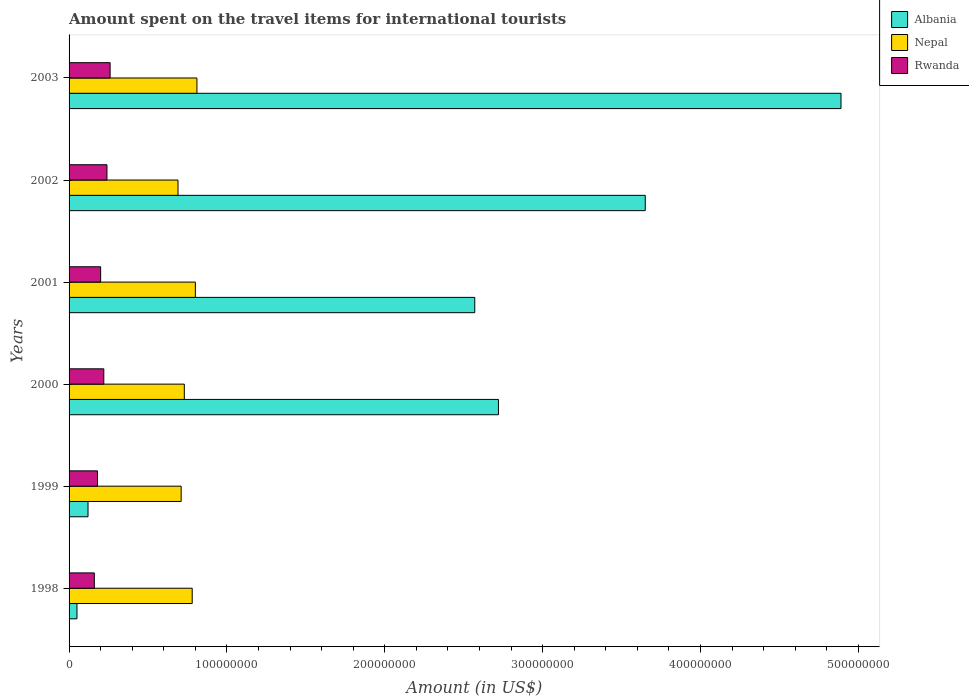How many groups of bars are there?
Make the answer very short. 6. How many bars are there on the 5th tick from the bottom?
Your answer should be compact. 3. What is the label of the 3rd group of bars from the top?
Your response must be concise. 2001. In how many cases, is the number of bars for a given year not equal to the number of legend labels?
Give a very brief answer. 0. What is the amount spent on the travel items for international tourists in Nepal in 2002?
Keep it short and to the point. 6.90e+07. Across all years, what is the maximum amount spent on the travel items for international tourists in Nepal?
Your response must be concise. 8.10e+07. Across all years, what is the minimum amount spent on the travel items for international tourists in Nepal?
Keep it short and to the point. 6.90e+07. What is the total amount spent on the travel items for international tourists in Albania in the graph?
Your answer should be very brief. 1.40e+09. What is the difference between the amount spent on the travel items for international tourists in Nepal in 2001 and that in 2002?
Provide a succinct answer. 1.10e+07. What is the difference between the amount spent on the travel items for international tourists in Albania in 1998 and the amount spent on the travel items for international tourists in Rwanda in 2002?
Give a very brief answer. -1.90e+07. What is the average amount spent on the travel items for international tourists in Rwanda per year?
Your response must be concise. 2.10e+07. In the year 2003, what is the difference between the amount spent on the travel items for international tourists in Nepal and amount spent on the travel items for international tourists in Rwanda?
Provide a succinct answer. 5.50e+07. In how many years, is the amount spent on the travel items for international tourists in Albania greater than 480000000 US$?
Offer a terse response. 1. Is the amount spent on the travel items for international tourists in Albania in 1998 less than that in 2003?
Your response must be concise. Yes. Is the difference between the amount spent on the travel items for international tourists in Nepal in 1999 and 2001 greater than the difference between the amount spent on the travel items for international tourists in Rwanda in 1999 and 2001?
Give a very brief answer. No. What is the difference between the highest and the lowest amount spent on the travel items for international tourists in Albania?
Your response must be concise. 4.84e+08. In how many years, is the amount spent on the travel items for international tourists in Albania greater than the average amount spent on the travel items for international tourists in Albania taken over all years?
Make the answer very short. 4. What does the 2nd bar from the top in 2000 represents?
Give a very brief answer. Nepal. What does the 2nd bar from the bottom in 2003 represents?
Your answer should be compact. Nepal. Is it the case that in every year, the sum of the amount spent on the travel items for international tourists in Rwanda and amount spent on the travel items for international tourists in Nepal is greater than the amount spent on the travel items for international tourists in Albania?
Your answer should be compact. No. How many bars are there?
Keep it short and to the point. 18. Are all the bars in the graph horizontal?
Give a very brief answer. Yes. How many years are there in the graph?
Your answer should be compact. 6. What is the difference between two consecutive major ticks on the X-axis?
Provide a short and direct response. 1.00e+08. Are the values on the major ticks of X-axis written in scientific E-notation?
Your response must be concise. No. Where does the legend appear in the graph?
Keep it short and to the point. Top right. How many legend labels are there?
Offer a very short reply. 3. What is the title of the graph?
Offer a very short reply. Amount spent on the travel items for international tourists. What is the label or title of the X-axis?
Make the answer very short. Amount (in US$). What is the Amount (in US$) in Albania in 1998?
Your answer should be very brief. 5.00e+06. What is the Amount (in US$) in Nepal in 1998?
Make the answer very short. 7.80e+07. What is the Amount (in US$) of Rwanda in 1998?
Your answer should be compact. 1.60e+07. What is the Amount (in US$) in Albania in 1999?
Your answer should be very brief. 1.20e+07. What is the Amount (in US$) of Nepal in 1999?
Your answer should be very brief. 7.10e+07. What is the Amount (in US$) of Rwanda in 1999?
Make the answer very short. 1.80e+07. What is the Amount (in US$) of Albania in 2000?
Make the answer very short. 2.72e+08. What is the Amount (in US$) in Nepal in 2000?
Provide a succinct answer. 7.30e+07. What is the Amount (in US$) of Rwanda in 2000?
Provide a succinct answer. 2.20e+07. What is the Amount (in US$) of Albania in 2001?
Keep it short and to the point. 2.57e+08. What is the Amount (in US$) of Nepal in 2001?
Ensure brevity in your answer.  8.00e+07. What is the Amount (in US$) of Rwanda in 2001?
Offer a terse response. 2.00e+07. What is the Amount (in US$) in Albania in 2002?
Provide a succinct answer. 3.65e+08. What is the Amount (in US$) of Nepal in 2002?
Keep it short and to the point. 6.90e+07. What is the Amount (in US$) of Rwanda in 2002?
Give a very brief answer. 2.40e+07. What is the Amount (in US$) of Albania in 2003?
Offer a terse response. 4.89e+08. What is the Amount (in US$) in Nepal in 2003?
Provide a short and direct response. 8.10e+07. What is the Amount (in US$) in Rwanda in 2003?
Give a very brief answer. 2.60e+07. Across all years, what is the maximum Amount (in US$) of Albania?
Give a very brief answer. 4.89e+08. Across all years, what is the maximum Amount (in US$) in Nepal?
Your response must be concise. 8.10e+07. Across all years, what is the maximum Amount (in US$) of Rwanda?
Ensure brevity in your answer.  2.60e+07. Across all years, what is the minimum Amount (in US$) of Albania?
Provide a succinct answer. 5.00e+06. Across all years, what is the minimum Amount (in US$) in Nepal?
Provide a short and direct response. 6.90e+07. Across all years, what is the minimum Amount (in US$) in Rwanda?
Ensure brevity in your answer.  1.60e+07. What is the total Amount (in US$) in Albania in the graph?
Provide a succinct answer. 1.40e+09. What is the total Amount (in US$) of Nepal in the graph?
Your answer should be very brief. 4.52e+08. What is the total Amount (in US$) in Rwanda in the graph?
Keep it short and to the point. 1.26e+08. What is the difference between the Amount (in US$) in Albania in 1998 and that in 1999?
Make the answer very short. -7.00e+06. What is the difference between the Amount (in US$) in Albania in 1998 and that in 2000?
Provide a succinct answer. -2.67e+08. What is the difference between the Amount (in US$) in Nepal in 1998 and that in 2000?
Offer a very short reply. 5.00e+06. What is the difference between the Amount (in US$) in Rwanda in 1998 and that in 2000?
Ensure brevity in your answer.  -6.00e+06. What is the difference between the Amount (in US$) in Albania in 1998 and that in 2001?
Offer a terse response. -2.52e+08. What is the difference between the Amount (in US$) in Albania in 1998 and that in 2002?
Make the answer very short. -3.60e+08. What is the difference between the Amount (in US$) of Nepal in 1998 and that in 2002?
Provide a short and direct response. 9.00e+06. What is the difference between the Amount (in US$) in Rwanda in 1998 and that in 2002?
Offer a terse response. -8.00e+06. What is the difference between the Amount (in US$) of Albania in 1998 and that in 2003?
Offer a very short reply. -4.84e+08. What is the difference between the Amount (in US$) in Rwanda in 1998 and that in 2003?
Your answer should be very brief. -1.00e+07. What is the difference between the Amount (in US$) of Albania in 1999 and that in 2000?
Your response must be concise. -2.60e+08. What is the difference between the Amount (in US$) of Albania in 1999 and that in 2001?
Provide a short and direct response. -2.45e+08. What is the difference between the Amount (in US$) in Nepal in 1999 and that in 2001?
Offer a very short reply. -9.00e+06. What is the difference between the Amount (in US$) of Rwanda in 1999 and that in 2001?
Your answer should be compact. -2.00e+06. What is the difference between the Amount (in US$) in Albania in 1999 and that in 2002?
Your response must be concise. -3.53e+08. What is the difference between the Amount (in US$) in Nepal in 1999 and that in 2002?
Offer a very short reply. 2.00e+06. What is the difference between the Amount (in US$) of Rwanda in 1999 and that in 2002?
Provide a succinct answer. -6.00e+06. What is the difference between the Amount (in US$) in Albania in 1999 and that in 2003?
Offer a very short reply. -4.77e+08. What is the difference between the Amount (in US$) of Nepal in 1999 and that in 2003?
Your response must be concise. -1.00e+07. What is the difference between the Amount (in US$) of Rwanda in 1999 and that in 2003?
Ensure brevity in your answer.  -8.00e+06. What is the difference between the Amount (in US$) in Albania in 2000 and that in 2001?
Offer a very short reply. 1.50e+07. What is the difference between the Amount (in US$) in Nepal in 2000 and that in 2001?
Your answer should be compact. -7.00e+06. What is the difference between the Amount (in US$) in Albania in 2000 and that in 2002?
Provide a short and direct response. -9.30e+07. What is the difference between the Amount (in US$) of Nepal in 2000 and that in 2002?
Keep it short and to the point. 4.00e+06. What is the difference between the Amount (in US$) of Albania in 2000 and that in 2003?
Make the answer very short. -2.17e+08. What is the difference between the Amount (in US$) of Nepal in 2000 and that in 2003?
Offer a very short reply. -8.00e+06. What is the difference between the Amount (in US$) in Rwanda in 2000 and that in 2003?
Provide a succinct answer. -4.00e+06. What is the difference between the Amount (in US$) of Albania in 2001 and that in 2002?
Make the answer very short. -1.08e+08. What is the difference between the Amount (in US$) in Nepal in 2001 and that in 2002?
Make the answer very short. 1.10e+07. What is the difference between the Amount (in US$) of Rwanda in 2001 and that in 2002?
Make the answer very short. -4.00e+06. What is the difference between the Amount (in US$) in Albania in 2001 and that in 2003?
Make the answer very short. -2.32e+08. What is the difference between the Amount (in US$) in Rwanda in 2001 and that in 2003?
Provide a succinct answer. -6.00e+06. What is the difference between the Amount (in US$) in Albania in 2002 and that in 2003?
Offer a terse response. -1.24e+08. What is the difference between the Amount (in US$) of Nepal in 2002 and that in 2003?
Your answer should be compact. -1.20e+07. What is the difference between the Amount (in US$) of Rwanda in 2002 and that in 2003?
Make the answer very short. -2.00e+06. What is the difference between the Amount (in US$) in Albania in 1998 and the Amount (in US$) in Nepal in 1999?
Give a very brief answer. -6.60e+07. What is the difference between the Amount (in US$) of Albania in 1998 and the Amount (in US$) of Rwanda in 1999?
Your answer should be compact. -1.30e+07. What is the difference between the Amount (in US$) in Nepal in 1998 and the Amount (in US$) in Rwanda in 1999?
Provide a short and direct response. 6.00e+07. What is the difference between the Amount (in US$) in Albania in 1998 and the Amount (in US$) in Nepal in 2000?
Make the answer very short. -6.80e+07. What is the difference between the Amount (in US$) in Albania in 1998 and the Amount (in US$) in Rwanda in 2000?
Keep it short and to the point. -1.70e+07. What is the difference between the Amount (in US$) of Nepal in 1998 and the Amount (in US$) of Rwanda in 2000?
Your response must be concise. 5.60e+07. What is the difference between the Amount (in US$) of Albania in 1998 and the Amount (in US$) of Nepal in 2001?
Offer a terse response. -7.50e+07. What is the difference between the Amount (in US$) in Albania in 1998 and the Amount (in US$) in Rwanda in 2001?
Your answer should be very brief. -1.50e+07. What is the difference between the Amount (in US$) of Nepal in 1998 and the Amount (in US$) of Rwanda in 2001?
Give a very brief answer. 5.80e+07. What is the difference between the Amount (in US$) in Albania in 1998 and the Amount (in US$) in Nepal in 2002?
Offer a very short reply. -6.40e+07. What is the difference between the Amount (in US$) in Albania in 1998 and the Amount (in US$) in Rwanda in 2002?
Give a very brief answer. -1.90e+07. What is the difference between the Amount (in US$) of Nepal in 1998 and the Amount (in US$) of Rwanda in 2002?
Ensure brevity in your answer.  5.40e+07. What is the difference between the Amount (in US$) of Albania in 1998 and the Amount (in US$) of Nepal in 2003?
Your response must be concise. -7.60e+07. What is the difference between the Amount (in US$) in Albania in 1998 and the Amount (in US$) in Rwanda in 2003?
Offer a very short reply. -2.10e+07. What is the difference between the Amount (in US$) in Nepal in 1998 and the Amount (in US$) in Rwanda in 2003?
Your response must be concise. 5.20e+07. What is the difference between the Amount (in US$) in Albania in 1999 and the Amount (in US$) in Nepal in 2000?
Make the answer very short. -6.10e+07. What is the difference between the Amount (in US$) in Albania in 1999 and the Amount (in US$) in Rwanda in 2000?
Offer a terse response. -1.00e+07. What is the difference between the Amount (in US$) in Nepal in 1999 and the Amount (in US$) in Rwanda in 2000?
Provide a succinct answer. 4.90e+07. What is the difference between the Amount (in US$) in Albania in 1999 and the Amount (in US$) in Nepal in 2001?
Provide a succinct answer. -6.80e+07. What is the difference between the Amount (in US$) in Albania in 1999 and the Amount (in US$) in Rwanda in 2001?
Provide a succinct answer. -8.00e+06. What is the difference between the Amount (in US$) of Nepal in 1999 and the Amount (in US$) of Rwanda in 2001?
Provide a succinct answer. 5.10e+07. What is the difference between the Amount (in US$) in Albania in 1999 and the Amount (in US$) in Nepal in 2002?
Ensure brevity in your answer.  -5.70e+07. What is the difference between the Amount (in US$) in Albania in 1999 and the Amount (in US$) in Rwanda in 2002?
Give a very brief answer. -1.20e+07. What is the difference between the Amount (in US$) of Nepal in 1999 and the Amount (in US$) of Rwanda in 2002?
Offer a terse response. 4.70e+07. What is the difference between the Amount (in US$) in Albania in 1999 and the Amount (in US$) in Nepal in 2003?
Your answer should be compact. -6.90e+07. What is the difference between the Amount (in US$) of Albania in 1999 and the Amount (in US$) of Rwanda in 2003?
Give a very brief answer. -1.40e+07. What is the difference between the Amount (in US$) of Nepal in 1999 and the Amount (in US$) of Rwanda in 2003?
Give a very brief answer. 4.50e+07. What is the difference between the Amount (in US$) in Albania in 2000 and the Amount (in US$) in Nepal in 2001?
Provide a short and direct response. 1.92e+08. What is the difference between the Amount (in US$) of Albania in 2000 and the Amount (in US$) of Rwanda in 2001?
Your answer should be very brief. 2.52e+08. What is the difference between the Amount (in US$) in Nepal in 2000 and the Amount (in US$) in Rwanda in 2001?
Provide a succinct answer. 5.30e+07. What is the difference between the Amount (in US$) in Albania in 2000 and the Amount (in US$) in Nepal in 2002?
Offer a terse response. 2.03e+08. What is the difference between the Amount (in US$) of Albania in 2000 and the Amount (in US$) of Rwanda in 2002?
Make the answer very short. 2.48e+08. What is the difference between the Amount (in US$) in Nepal in 2000 and the Amount (in US$) in Rwanda in 2002?
Provide a short and direct response. 4.90e+07. What is the difference between the Amount (in US$) of Albania in 2000 and the Amount (in US$) of Nepal in 2003?
Provide a short and direct response. 1.91e+08. What is the difference between the Amount (in US$) in Albania in 2000 and the Amount (in US$) in Rwanda in 2003?
Make the answer very short. 2.46e+08. What is the difference between the Amount (in US$) of Nepal in 2000 and the Amount (in US$) of Rwanda in 2003?
Offer a very short reply. 4.70e+07. What is the difference between the Amount (in US$) of Albania in 2001 and the Amount (in US$) of Nepal in 2002?
Provide a short and direct response. 1.88e+08. What is the difference between the Amount (in US$) in Albania in 2001 and the Amount (in US$) in Rwanda in 2002?
Make the answer very short. 2.33e+08. What is the difference between the Amount (in US$) of Nepal in 2001 and the Amount (in US$) of Rwanda in 2002?
Your answer should be compact. 5.60e+07. What is the difference between the Amount (in US$) of Albania in 2001 and the Amount (in US$) of Nepal in 2003?
Your answer should be very brief. 1.76e+08. What is the difference between the Amount (in US$) of Albania in 2001 and the Amount (in US$) of Rwanda in 2003?
Provide a succinct answer. 2.31e+08. What is the difference between the Amount (in US$) in Nepal in 2001 and the Amount (in US$) in Rwanda in 2003?
Ensure brevity in your answer.  5.40e+07. What is the difference between the Amount (in US$) in Albania in 2002 and the Amount (in US$) in Nepal in 2003?
Your response must be concise. 2.84e+08. What is the difference between the Amount (in US$) of Albania in 2002 and the Amount (in US$) of Rwanda in 2003?
Keep it short and to the point. 3.39e+08. What is the difference between the Amount (in US$) of Nepal in 2002 and the Amount (in US$) of Rwanda in 2003?
Provide a succinct answer. 4.30e+07. What is the average Amount (in US$) in Albania per year?
Ensure brevity in your answer.  2.33e+08. What is the average Amount (in US$) in Nepal per year?
Keep it short and to the point. 7.53e+07. What is the average Amount (in US$) in Rwanda per year?
Offer a terse response. 2.10e+07. In the year 1998, what is the difference between the Amount (in US$) of Albania and Amount (in US$) of Nepal?
Make the answer very short. -7.30e+07. In the year 1998, what is the difference between the Amount (in US$) of Albania and Amount (in US$) of Rwanda?
Ensure brevity in your answer.  -1.10e+07. In the year 1998, what is the difference between the Amount (in US$) of Nepal and Amount (in US$) of Rwanda?
Your response must be concise. 6.20e+07. In the year 1999, what is the difference between the Amount (in US$) of Albania and Amount (in US$) of Nepal?
Offer a very short reply. -5.90e+07. In the year 1999, what is the difference between the Amount (in US$) of Albania and Amount (in US$) of Rwanda?
Provide a succinct answer. -6.00e+06. In the year 1999, what is the difference between the Amount (in US$) in Nepal and Amount (in US$) in Rwanda?
Your answer should be very brief. 5.30e+07. In the year 2000, what is the difference between the Amount (in US$) of Albania and Amount (in US$) of Nepal?
Offer a very short reply. 1.99e+08. In the year 2000, what is the difference between the Amount (in US$) in Albania and Amount (in US$) in Rwanda?
Your answer should be compact. 2.50e+08. In the year 2000, what is the difference between the Amount (in US$) of Nepal and Amount (in US$) of Rwanda?
Keep it short and to the point. 5.10e+07. In the year 2001, what is the difference between the Amount (in US$) of Albania and Amount (in US$) of Nepal?
Make the answer very short. 1.77e+08. In the year 2001, what is the difference between the Amount (in US$) of Albania and Amount (in US$) of Rwanda?
Offer a terse response. 2.37e+08. In the year 2001, what is the difference between the Amount (in US$) of Nepal and Amount (in US$) of Rwanda?
Ensure brevity in your answer.  6.00e+07. In the year 2002, what is the difference between the Amount (in US$) in Albania and Amount (in US$) in Nepal?
Give a very brief answer. 2.96e+08. In the year 2002, what is the difference between the Amount (in US$) of Albania and Amount (in US$) of Rwanda?
Keep it short and to the point. 3.41e+08. In the year 2002, what is the difference between the Amount (in US$) in Nepal and Amount (in US$) in Rwanda?
Your response must be concise. 4.50e+07. In the year 2003, what is the difference between the Amount (in US$) in Albania and Amount (in US$) in Nepal?
Your answer should be very brief. 4.08e+08. In the year 2003, what is the difference between the Amount (in US$) in Albania and Amount (in US$) in Rwanda?
Make the answer very short. 4.63e+08. In the year 2003, what is the difference between the Amount (in US$) of Nepal and Amount (in US$) of Rwanda?
Offer a very short reply. 5.50e+07. What is the ratio of the Amount (in US$) in Albania in 1998 to that in 1999?
Offer a very short reply. 0.42. What is the ratio of the Amount (in US$) in Nepal in 1998 to that in 1999?
Provide a succinct answer. 1.1. What is the ratio of the Amount (in US$) of Albania in 1998 to that in 2000?
Keep it short and to the point. 0.02. What is the ratio of the Amount (in US$) of Nepal in 1998 to that in 2000?
Your answer should be very brief. 1.07. What is the ratio of the Amount (in US$) of Rwanda in 1998 to that in 2000?
Provide a short and direct response. 0.73. What is the ratio of the Amount (in US$) of Albania in 1998 to that in 2001?
Provide a succinct answer. 0.02. What is the ratio of the Amount (in US$) in Nepal in 1998 to that in 2001?
Your answer should be compact. 0.97. What is the ratio of the Amount (in US$) of Albania in 1998 to that in 2002?
Offer a very short reply. 0.01. What is the ratio of the Amount (in US$) in Nepal in 1998 to that in 2002?
Keep it short and to the point. 1.13. What is the ratio of the Amount (in US$) in Albania in 1998 to that in 2003?
Ensure brevity in your answer.  0.01. What is the ratio of the Amount (in US$) in Nepal in 1998 to that in 2003?
Offer a terse response. 0.96. What is the ratio of the Amount (in US$) in Rwanda in 1998 to that in 2003?
Make the answer very short. 0.62. What is the ratio of the Amount (in US$) of Albania in 1999 to that in 2000?
Make the answer very short. 0.04. What is the ratio of the Amount (in US$) of Nepal in 1999 to that in 2000?
Give a very brief answer. 0.97. What is the ratio of the Amount (in US$) of Rwanda in 1999 to that in 2000?
Provide a short and direct response. 0.82. What is the ratio of the Amount (in US$) of Albania in 1999 to that in 2001?
Make the answer very short. 0.05. What is the ratio of the Amount (in US$) in Nepal in 1999 to that in 2001?
Give a very brief answer. 0.89. What is the ratio of the Amount (in US$) of Rwanda in 1999 to that in 2001?
Provide a succinct answer. 0.9. What is the ratio of the Amount (in US$) in Albania in 1999 to that in 2002?
Provide a short and direct response. 0.03. What is the ratio of the Amount (in US$) in Rwanda in 1999 to that in 2002?
Keep it short and to the point. 0.75. What is the ratio of the Amount (in US$) in Albania in 1999 to that in 2003?
Offer a very short reply. 0.02. What is the ratio of the Amount (in US$) of Nepal in 1999 to that in 2003?
Ensure brevity in your answer.  0.88. What is the ratio of the Amount (in US$) in Rwanda in 1999 to that in 2003?
Provide a short and direct response. 0.69. What is the ratio of the Amount (in US$) of Albania in 2000 to that in 2001?
Ensure brevity in your answer.  1.06. What is the ratio of the Amount (in US$) in Nepal in 2000 to that in 2001?
Your response must be concise. 0.91. What is the ratio of the Amount (in US$) of Albania in 2000 to that in 2002?
Your answer should be very brief. 0.75. What is the ratio of the Amount (in US$) in Nepal in 2000 to that in 2002?
Provide a succinct answer. 1.06. What is the ratio of the Amount (in US$) in Rwanda in 2000 to that in 2002?
Your answer should be very brief. 0.92. What is the ratio of the Amount (in US$) of Albania in 2000 to that in 2003?
Your answer should be very brief. 0.56. What is the ratio of the Amount (in US$) of Nepal in 2000 to that in 2003?
Your answer should be very brief. 0.9. What is the ratio of the Amount (in US$) of Rwanda in 2000 to that in 2003?
Ensure brevity in your answer.  0.85. What is the ratio of the Amount (in US$) in Albania in 2001 to that in 2002?
Offer a terse response. 0.7. What is the ratio of the Amount (in US$) of Nepal in 2001 to that in 2002?
Your response must be concise. 1.16. What is the ratio of the Amount (in US$) in Rwanda in 2001 to that in 2002?
Make the answer very short. 0.83. What is the ratio of the Amount (in US$) in Albania in 2001 to that in 2003?
Give a very brief answer. 0.53. What is the ratio of the Amount (in US$) of Rwanda in 2001 to that in 2003?
Keep it short and to the point. 0.77. What is the ratio of the Amount (in US$) in Albania in 2002 to that in 2003?
Offer a terse response. 0.75. What is the ratio of the Amount (in US$) of Nepal in 2002 to that in 2003?
Ensure brevity in your answer.  0.85. What is the difference between the highest and the second highest Amount (in US$) of Albania?
Provide a succinct answer. 1.24e+08. What is the difference between the highest and the second highest Amount (in US$) of Rwanda?
Your response must be concise. 2.00e+06. What is the difference between the highest and the lowest Amount (in US$) of Albania?
Your answer should be very brief. 4.84e+08. What is the difference between the highest and the lowest Amount (in US$) in Rwanda?
Your answer should be compact. 1.00e+07. 